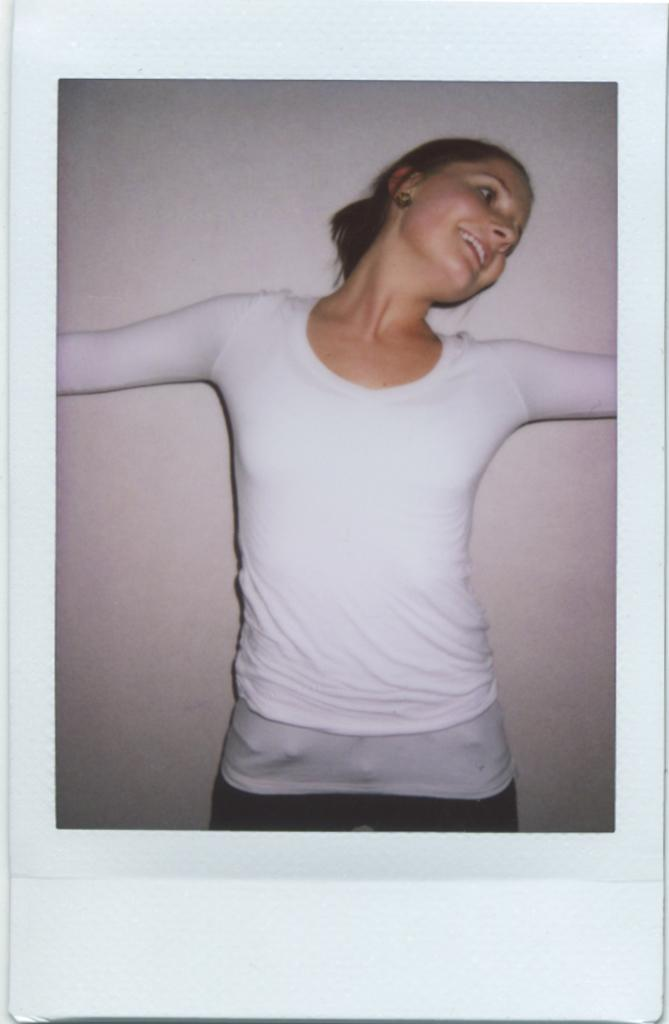Who is present in the image? There is a woman in the image. What is the woman doing in the image? The woman is standing. What can be seen in the background of the image? There is a wall visible in the background of the image. What type of question is being asked by the woman in the image? There is no indication in the image that the woman is asking a question, as her actions and the visible elements do not suggest any interaction or communication. 